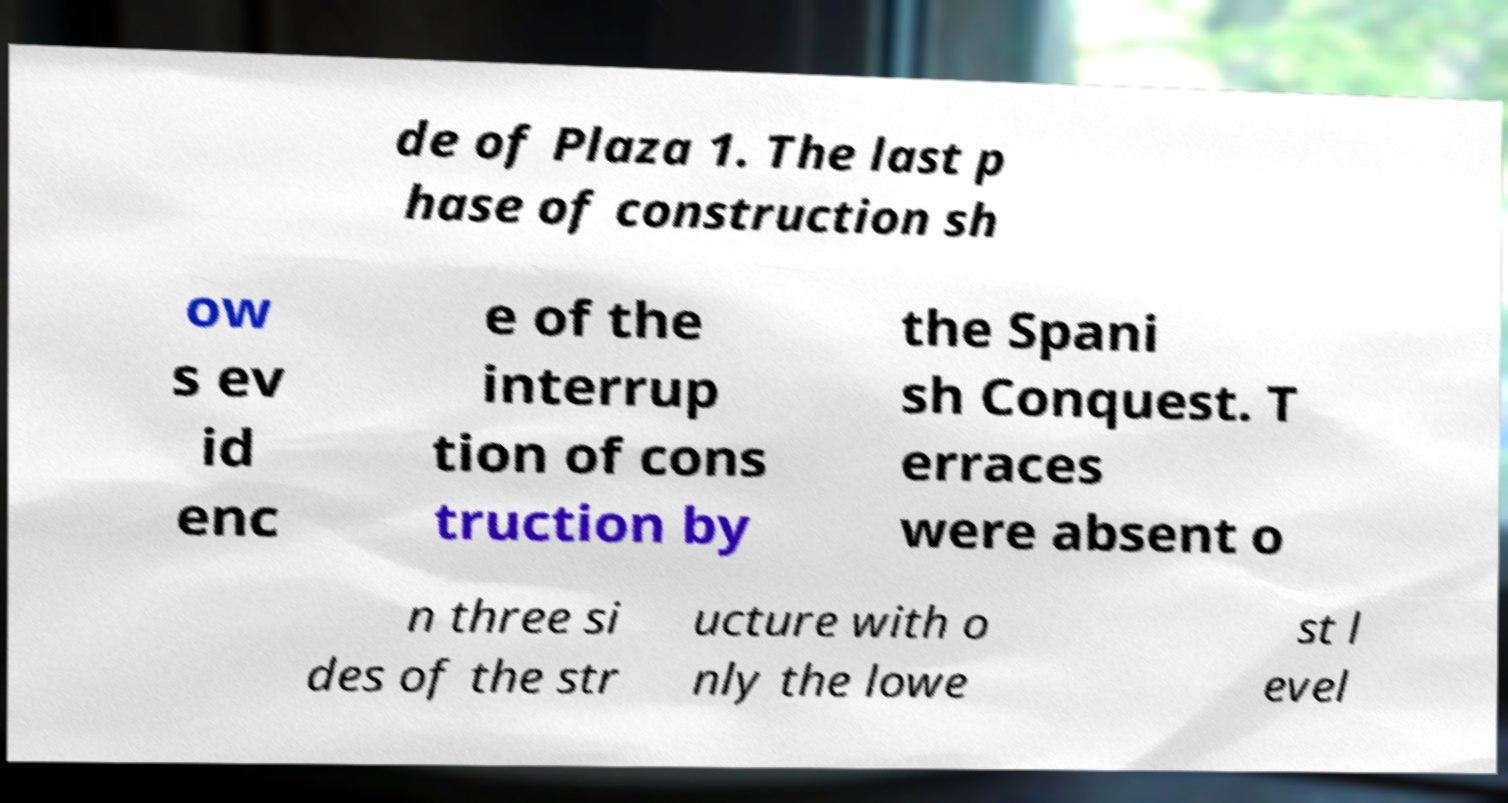Could you assist in decoding the text presented in this image and type it out clearly? de of Plaza 1. The last p hase of construction sh ow s ev id enc e of the interrup tion of cons truction by the Spani sh Conquest. T erraces were absent o n three si des of the str ucture with o nly the lowe st l evel 